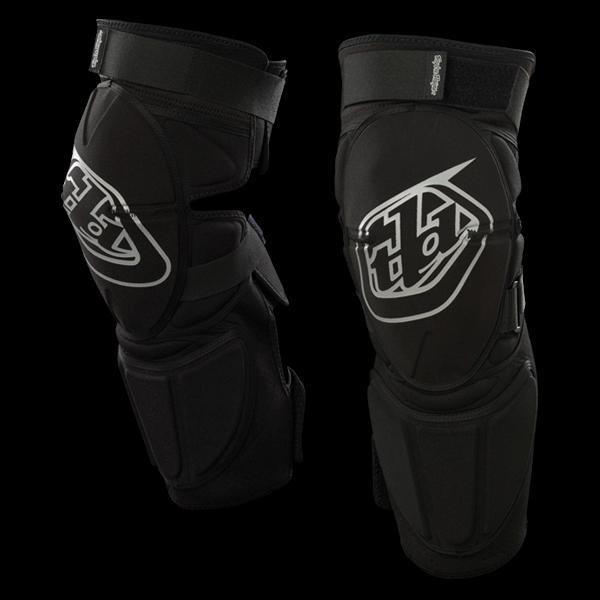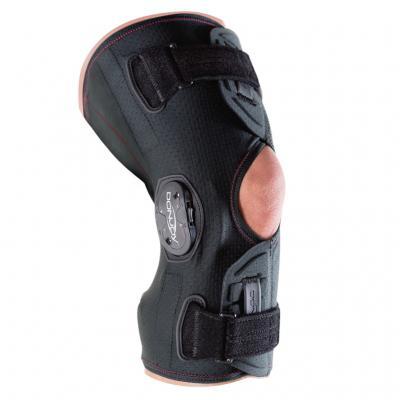The first image is the image on the left, the second image is the image on the right. Considering the images on both sides, is "The pads are facing left in both images." valid? Answer yes or no. No. The first image is the image on the left, the second image is the image on the right. For the images shown, is this caption "The only colors on the knee pads are black and white." true? Answer yes or no. Yes. 